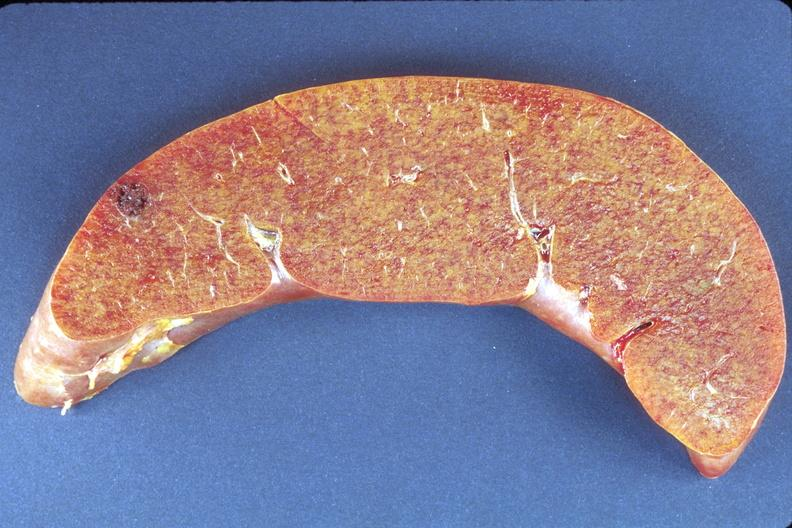what is present?
Answer the question using a single word or phrase. Hepatobiliary 